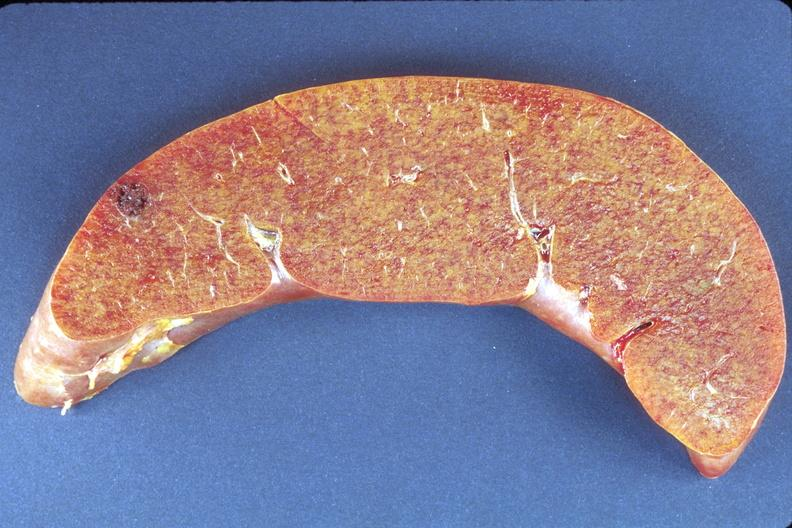what is present?
Answer the question using a single word or phrase. Hepatobiliary 